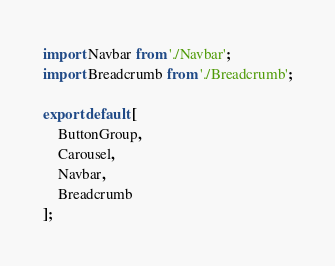Convert code to text. <code><loc_0><loc_0><loc_500><loc_500><_JavaScript_>import Navbar from './Navbar';
import Breadcrumb from './Breadcrumb';

export default [
	ButtonGroup,
	Carousel,
	Navbar,
	Breadcrumb
];</code> 